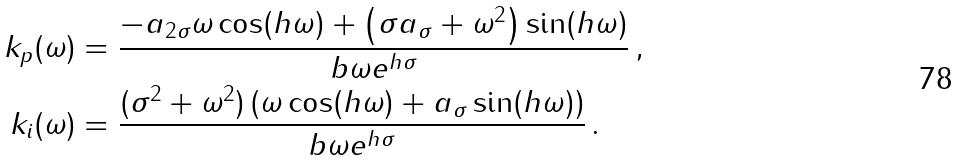<formula> <loc_0><loc_0><loc_500><loc_500>k _ { p } ( \omega ) & = \frac { - a _ { 2 \sigma } \omega \cos ( h \omega ) + \left ( \sigma a _ { \sigma } + \omega ^ { 2 } \right ) \sin ( h \omega ) } { b \omega e ^ { h \sigma } } \, , \\ k _ { i } ( \omega ) & = \frac { ( \sigma ^ { 2 } + \omega ^ { 2 } ) \left ( \omega \cos ( h \omega ) + a _ { \sigma } \sin ( h \omega ) \right ) } { b \omega e ^ { h \sigma } } \, .</formula> 